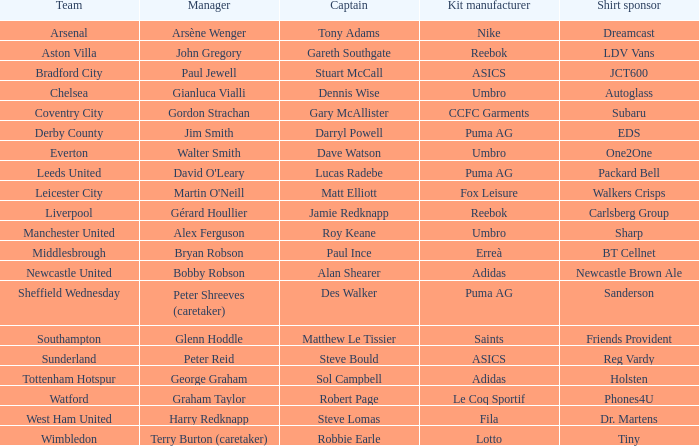Which Kit manufacturer sponsers Arsenal? Nike. 